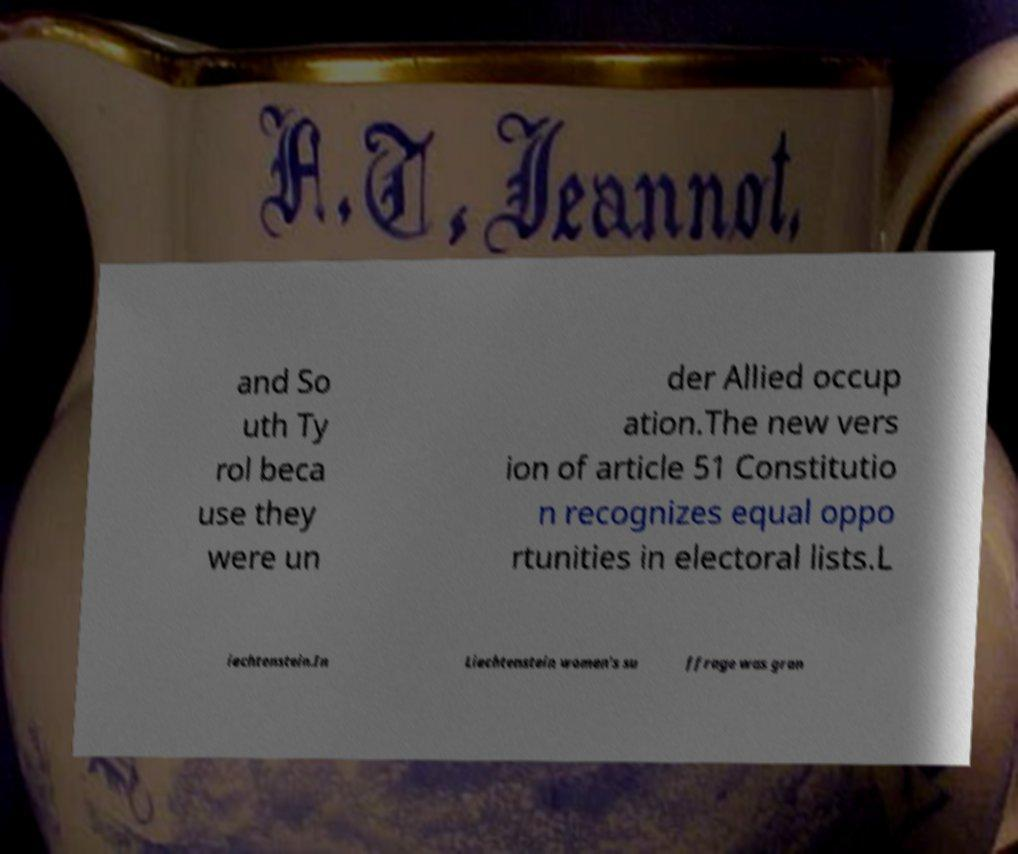Could you assist in decoding the text presented in this image and type it out clearly? and So uth Ty rol beca use they were un der Allied occup ation.The new vers ion of article 51 Constitutio n recognizes equal oppo rtunities in electoral lists.L iechtenstein.In Liechtenstein women's su ffrage was gran 